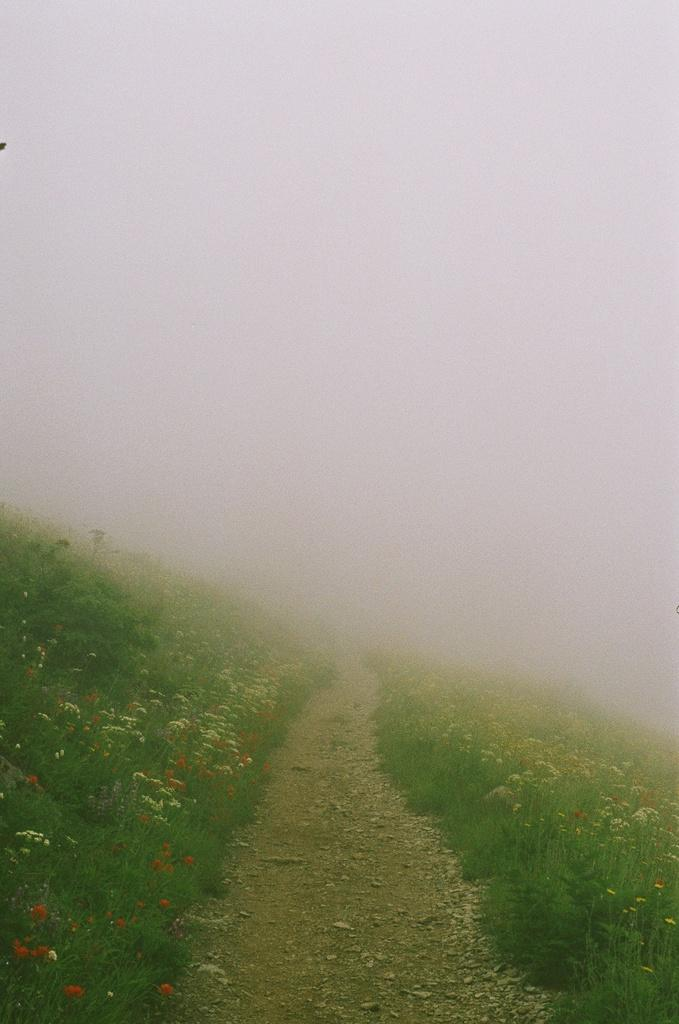What type of vegetation is present on the ground in the image? There is grass and plants with flowers on the ground in the image. What can be seen on the path in the middle of the image? There are stones on a path in the middle of the image. What is visible in the background of the image? The background of the image includes fog. What type of beef can be seen hanging from the trees in the image? There is no beef present in the image; it features grass, plants with flowers, a path with stones, and a foggy background. How does the rainstorm affect the visibility of the path in the image? There is no rainstorm present in the image; it features a clear path with stones. 